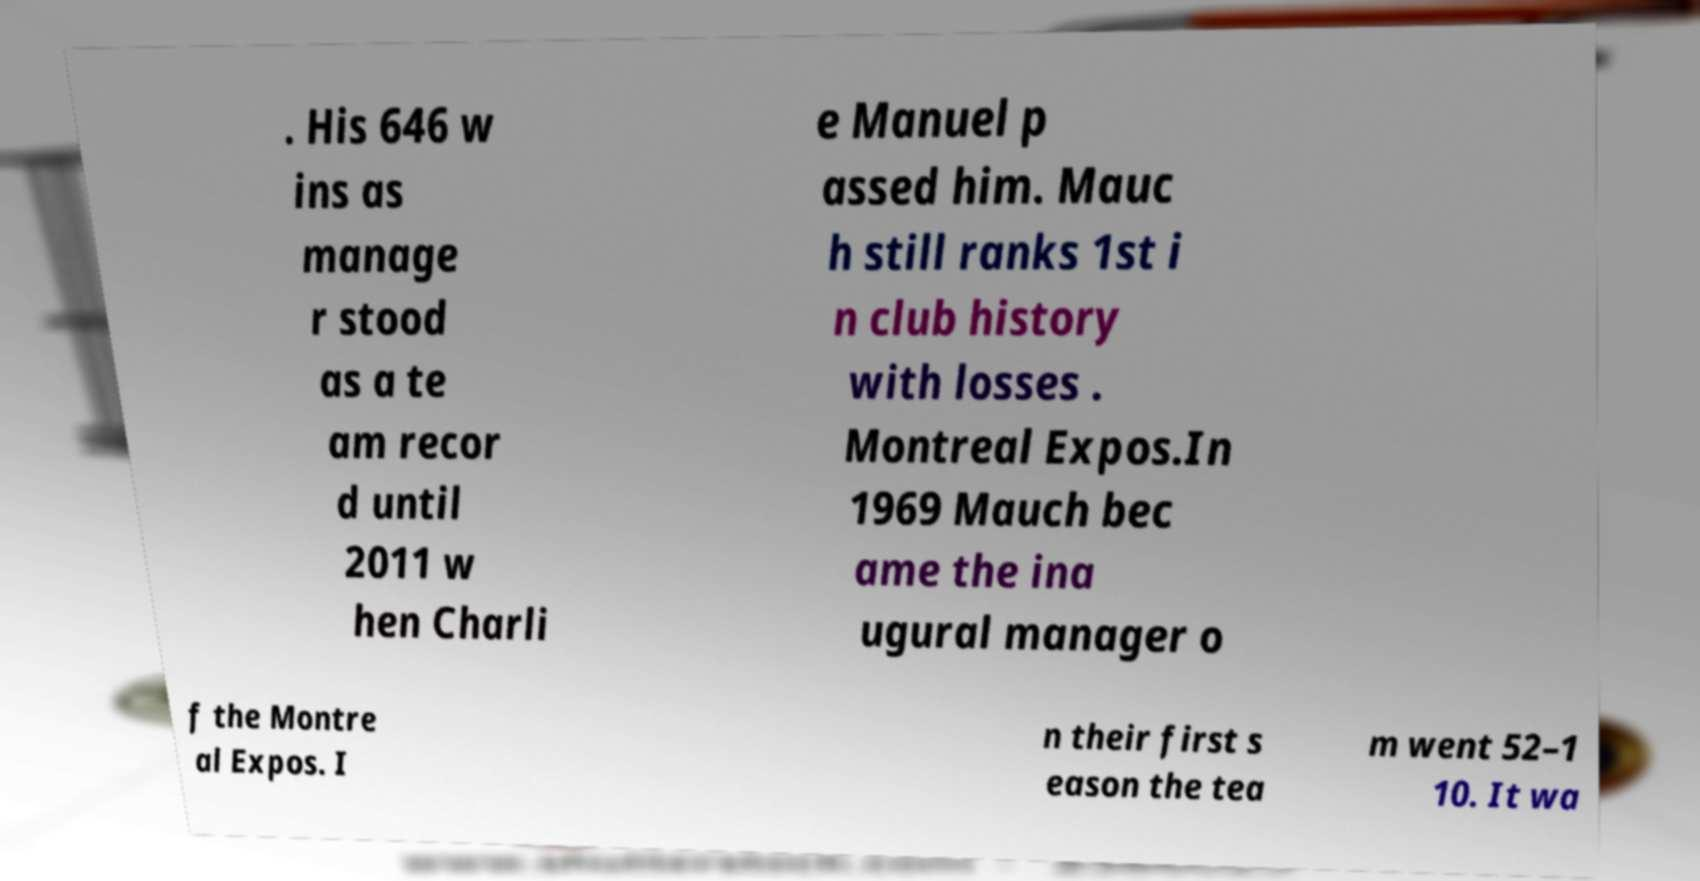Can you read and provide the text displayed in the image?This photo seems to have some interesting text. Can you extract and type it out for me? . His 646 w ins as manage r stood as a te am recor d until 2011 w hen Charli e Manuel p assed him. Mauc h still ranks 1st i n club history with losses . Montreal Expos.In 1969 Mauch bec ame the ina ugural manager o f the Montre al Expos. I n their first s eason the tea m went 52–1 10. It wa 